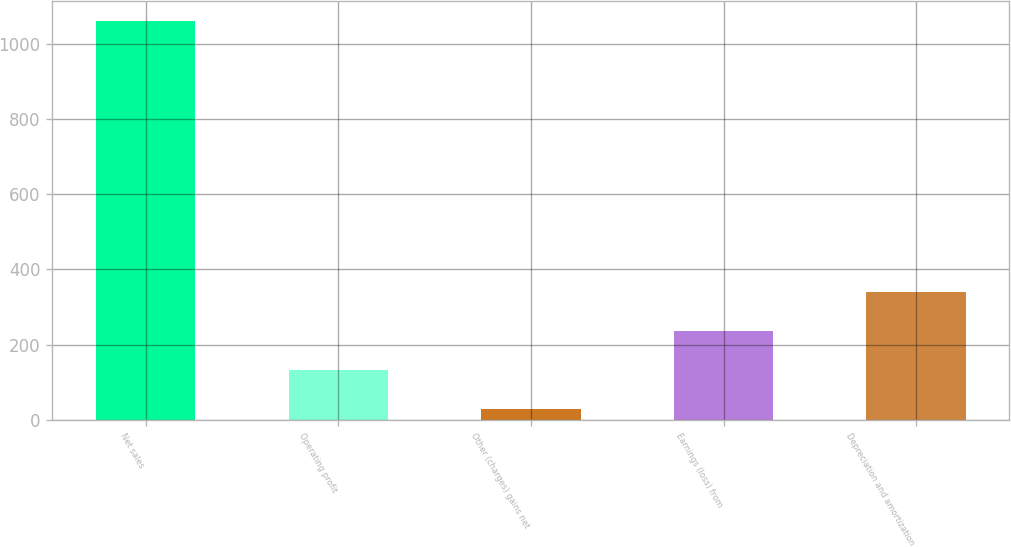Convert chart. <chart><loc_0><loc_0><loc_500><loc_500><bar_chart><fcel>Net sales<fcel>Operating profit<fcel>Other (charges) gains net<fcel>Earnings (loss) from<fcel>Depreciation and amortization<nl><fcel>1061<fcel>132.2<fcel>29<fcel>235.4<fcel>338.6<nl></chart> 